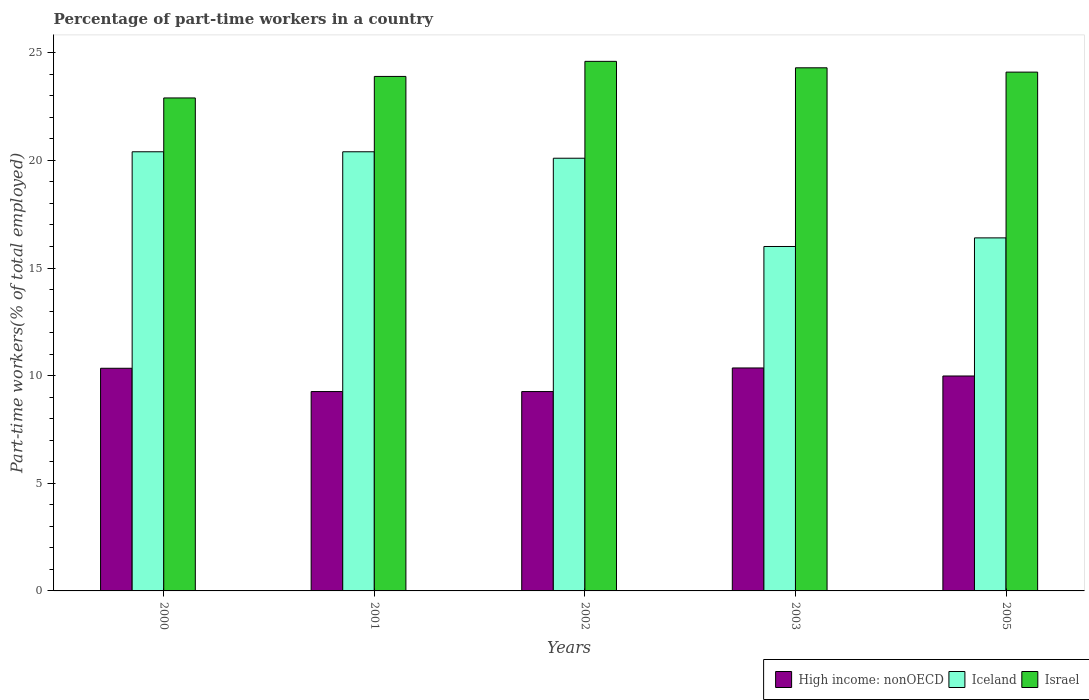How many different coloured bars are there?
Make the answer very short. 3. How many groups of bars are there?
Your answer should be compact. 5. Are the number of bars on each tick of the X-axis equal?
Your answer should be very brief. Yes. How many bars are there on the 1st tick from the left?
Offer a terse response. 3. What is the percentage of part-time workers in Israel in 2000?
Keep it short and to the point. 22.9. Across all years, what is the maximum percentage of part-time workers in High income: nonOECD?
Ensure brevity in your answer.  10.36. In which year was the percentage of part-time workers in Iceland minimum?
Give a very brief answer. 2003. What is the total percentage of part-time workers in Iceland in the graph?
Provide a succinct answer. 93.3. What is the difference between the percentage of part-time workers in Israel in 2000 and that in 2002?
Give a very brief answer. -1.7. What is the difference between the percentage of part-time workers in High income: nonOECD in 2001 and the percentage of part-time workers in Israel in 2002?
Make the answer very short. -15.34. What is the average percentage of part-time workers in High income: nonOECD per year?
Your response must be concise. 9.84. In the year 2005, what is the difference between the percentage of part-time workers in Israel and percentage of part-time workers in High income: nonOECD?
Ensure brevity in your answer.  14.12. What is the ratio of the percentage of part-time workers in Israel in 2002 to that in 2005?
Provide a short and direct response. 1.02. What is the difference between the highest and the lowest percentage of part-time workers in High income: nonOECD?
Your response must be concise. 1.1. What does the 1st bar from the left in 2002 represents?
Offer a very short reply. High income: nonOECD. What does the 3rd bar from the right in 2005 represents?
Provide a succinct answer. High income: nonOECD. Is it the case that in every year, the sum of the percentage of part-time workers in Iceland and percentage of part-time workers in Israel is greater than the percentage of part-time workers in High income: nonOECD?
Offer a very short reply. Yes. Are the values on the major ticks of Y-axis written in scientific E-notation?
Keep it short and to the point. No. Does the graph contain any zero values?
Offer a terse response. No. Does the graph contain grids?
Provide a short and direct response. No. How many legend labels are there?
Your answer should be compact. 3. How are the legend labels stacked?
Keep it short and to the point. Horizontal. What is the title of the graph?
Give a very brief answer. Percentage of part-time workers in a country. What is the label or title of the Y-axis?
Provide a short and direct response. Part-time workers(% of total employed). What is the Part-time workers(% of total employed) in High income: nonOECD in 2000?
Provide a succinct answer. 10.34. What is the Part-time workers(% of total employed) in Iceland in 2000?
Your answer should be very brief. 20.4. What is the Part-time workers(% of total employed) in Israel in 2000?
Provide a succinct answer. 22.9. What is the Part-time workers(% of total employed) in High income: nonOECD in 2001?
Ensure brevity in your answer.  9.26. What is the Part-time workers(% of total employed) of Iceland in 2001?
Your answer should be compact. 20.4. What is the Part-time workers(% of total employed) of Israel in 2001?
Ensure brevity in your answer.  23.9. What is the Part-time workers(% of total employed) of High income: nonOECD in 2002?
Offer a very short reply. 9.26. What is the Part-time workers(% of total employed) in Iceland in 2002?
Provide a succinct answer. 20.1. What is the Part-time workers(% of total employed) in Israel in 2002?
Make the answer very short. 24.6. What is the Part-time workers(% of total employed) of High income: nonOECD in 2003?
Your answer should be compact. 10.36. What is the Part-time workers(% of total employed) of Israel in 2003?
Offer a terse response. 24.3. What is the Part-time workers(% of total employed) in High income: nonOECD in 2005?
Keep it short and to the point. 9.98. What is the Part-time workers(% of total employed) of Iceland in 2005?
Keep it short and to the point. 16.4. What is the Part-time workers(% of total employed) in Israel in 2005?
Offer a very short reply. 24.1. Across all years, what is the maximum Part-time workers(% of total employed) in High income: nonOECD?
Your answer should be very brief. 10.36. Across all years, what is the maximum Part-time workers(% of total employed) in Iceland?
Make the answer very short. 20.4. Across all years, what is the maximum Part-time workers(% of total employed) of Israel?
Offer a very short reply. 24.6. Across all years, what is the minimum Part-time workers(% of total employed) in High income: nonOECD?
Offer a terse response. 9.26. Across all years, what is the minimum Part-time workers(% of total employed) of Israel?
Your response must be concise. 22.9. What is the total Part-time workers(% of total employed) of High income: nonOECD in the graph?
Your answer should be very brief. 49.21. What is the total Part-time workers(% of total employed) of Iceland in the graph?
Give a very brief answer. 93.3. What is the total Part-time workers(% of total employed) in Israel in the graph?
Your answer should be compact. 119.8. What is the difference between the Part-time workers(% of total employed) of High income: nonOECD in 2000 and that in 2001?
Make the answer very short. 1.08. What is the difference between the Part-time workers(% of total employed) in High income: nonOECD in 2000 and that in 2002?
Your answer should be compact. 1.08. What is the difference between the Part-time workers(% of total employed) in High income: nonOECD in 2000 and that in 2003?
Your answer should be compact. -0.01. What is the difference between the Part-time workers(% of total employed) of Israel in 2000 and that in 2003?
Provide a succinct answer. -1.4. What is the difference between the Part-time workers(% of total employed) in High income: nonOECD in 2000 and that in 2005?
Offer a very short reply. 0.36. What is the difference between the Part-time workers(% of total employed) in Iceland in 2000 and that in 2005?
Your answer should be very brief. 4. What is the difference between the Part-time workers(% of total employed) in High income: nonOECD in 2001 and that in 2002?
Your response must be concise. 0. What is the difference between the Part-time workers(% of total employed) in Iceland in 2001 and that in 2002?
Keep it short and to the point. 0.3. What is the difference between the Part-time workers(% of total employed) of Israel in 2001 and that in 2002?
Make the answer very short. -0.7. What is the difference between the Part-time workers(% of total employed) of High income: nonOECD in 2001 and that in 2003?
Your answer should be very brief. -1.1. What is the difference between the Part-time workers(% of total employed) of Iceland in 2001 and that in 2003?
Your response must be concise. 4.4. What is the difference between the Part-time workers(% of total employed) in High income: nonOECD in 2001 and that in 2005?
Offer a very short reply. -0.72. What is the difference between the Part-time workers(% of total employed) of Israel in 2001 and that in 2005?
Offer a terse response. -0.2. What is the difference between the Part-time workers(% of total employed) of High income: nonOECD in 2002 and that in 2003?
Provide a short and direct response. -1.1. What is the difference between the Part-time workers(% of total employed) in High income: nonOECD in 2002 and that in 2005?
Offer a very short reply. -0.72. What is the difference between the Part-time workers(% of total employed) in Iceland in 2002 and that in 2005?
Make the answer very short. 3.7. What is the difference between the Part-time workers(% of total employed) of High income: nonOECD in 2003 and that in 2005?
Ensure brevity in your answer.  0.37. What is the difference between the Part-time workers(% of total employed) of Iceland in 2003 and that in 2005?
Give a very brief answer. -0.4. What is the difference between the Part-time workers(% of total employed) of Israel in 2003 and that in 2005?
Provide a short and direct response. 0.2. What is the difference between the Part-time workers(% of total employed) of High income: nonOECD in 2000 and the Part-time workers(% of total employed) of Iceland in 2001?
Offer a terse response. -10.06. What is the difference between the Part-time workers(% of total employed) of High income: nonOECD in 2000 and the Part-time workers(% of total employed) of Israel in 2001?
Your answer should be compact. -13.56. What is the difference between the Part-time workers(% of total employed) in High income: nonOECD in 2000 and the Part-time workers(% of total employed) in Iceland in 2002?
Offer a very short reply. -9.76. What is the difference between the Part-time workers(% of total employed) in High income: nonOECD in 2000 and the Part-time workers(% of total employed) in Israel in 2002?
Give a very brief answer. -14.26. What is the difference between the Part-time workers(% of total employed) in Iceland in 2000 and the Part-time workers(% of total employed) in Israel in 2002?
Your answer should be very brief. -4.2. What is the difference between the Part-time workers(% of total employed) in High income: nonOECD in 2000 and the Part-time workers(% of total employed) in Iceland in 2003?
Your response must be concise. -5.66. What is the difference between the Part-time workers(% of total employed) in High income: nonOECD in 2000 and the Part-time workers(% of total employed) in Israel in 2003?
Keep it short and to the point. -13.96. What is the difference between the Part-time workers(% of total employed) of High income: nonOECD in 2000 and the Part-time workers(% of total employed) of Iceland in 2005?
Offer a very short reply. -6.06. What is the difference between the Part-time workers(% of total employed) in High income: nonOECD in 2000 and the Part-time workers(% of total employed) in Israel in 2005?
Provide a succinct answer. -13.76. What is the difference between the Part-time workers(% of total employed) of Iceland in 2000 and the Part-time workers(% of total employed) of Israel in 2005?
Provide a short and direct response. -3.7. What is the difference between the Part-time workers(% of total employed) of High income: nonOECD in 2001 and the Part-time workers(% of total employed) of Iceland in 2002?
Give a very brief answer. -10.84. What is the difference between the Part-time workers(% of total employed) in High income: nonOECD in 2001 and the Part-time workers(% of total employed) in Israel in 2002?
Your answer should be very brief. -15.34. What is the difference between the Part-time workers(% of total employed) in Iceland in 2001 and the Part-time workers(% of total employed) in Israel in 2002?
Give a very brief answer. -4.2. What is the difference between the Part-time workers(% of total employed) in High income: nonOECD in 2001 and the Part-time workers(% of total employed) in Iceland in 2003?
Make the answer very short. -6.74. What is the difference between the Part-time workers(% of total employed) in High income: nonOECD in 2001 and the Part-time workers(% of total employed) in Israel in 2003?
Keep it short and to the point. -15.04. What is the difference between the Part-time workers(% of total employed) of Iceland in 2001 and the Part-time workers(% of total employed) of Israel in 2003?
Your answer should be very brief. -3.9. What is the difference between the Part-time workers(% of total employed) of High income: nonOECD in 2001 and the Part-time workers(% of total employed) of Iceland in 2005?
Offer a terse response. -7.14. What is the difference between the Part-time workers(% of total employed) of High income: nonOECD in 2001 and the Part-time workers(% of total employed) of Israel in 2005?
Give a very brief answer. -14.84. What is the difference between the Part-time workers(% of total employed) in Iceland in 2001 and the Part-time workers(% of total employed) in Israel in 2005?
Your answer should be very brief. -3.7. What is the difference between the Part-time workers(% of total employed) of High income: nonOECD in 2002 and the Part-time workers(% of total employed) of Iceland in 2003?
Offer a terse response. -6.74. What is the difference between the Part-time workers(% of total employed) of High income: nonOECD in 2002 and the Part-time workers(% of total employed) of Israel in 2003?
Provide a succinct answer. -15.04. What is the difference between the Part-time workers(% of total employed) of High income: nonOECD in 2002 and the Part-time workers(% of total employed) of Iceland in 2005?
Make the answer very short. -7.14. What is the difference between the Part-time workers(% of total employed) of High income: nonOECD in 2002 and the Part-time workers(% of total employed) of Israel in 2005?
Make the answer very short. -14.84. What is the difference between the Part-time workers(% of total employed) of High income: nonOECD in 2003 and the Part-time workers(% of total employed) of Iceland in 2005?
Your answer should be very brief. -6.04. What is the difference between the Part-time workers(% of total employed) in High income: nonOECD in 2003 and the Part-time workers(% of total employed) in Israel in 2005?
Offer a very short reply. -13.74. What is the difference between the Part-time workers(% of total employed) in Iceland in 2003 and the Part-time workers(% of total employed) in Israel in 2005?
Ensure brevity in your answer.  -8.1. What is the average Part-time workers(% of total employed) in High income: nonOECD per year?
Offer a terse response. 9.84. What is the average Part-time workers(% of total employed) of Iceland per year?
Your answer should be compact. 18.66. What is the average Part-time workers(% of total employed) of Israel per year?
Keep it short and to the point. 23.96. In the year 2000, what is the difference between the Part-time workers(% of total employed) in High income: nonOECD and Part-time workers(% of total employed) in Iceland?
Provide a short and direct response. -10.06. In the year 2000, what is the difference between the Part-time workers(% of total employed) in High income: nonOECD and Part-time workers(% of total employed) in Israel?
Your answer should be very brief. -12.56. In the year 2001, what is the difference between the Part-time workers(% of total employed) in High income: nonOECD and Part-time workers(% of total employed) in Iceland?
Your answer should be very brief. -11.14. In the year 2001, what is the difference between the Part-time workers(% of total employed) of High income: nonOECD and Part-time workers(% of total employed) of Israel?
Offer a terse response. -14.64. In the year 2002, what is the difference between the Part-time workers(% of total employed) in High income: nonOECD and Part-time workers(% of total employed) in Iceland?
Give a very brief answer. -10.84. In the year 2002, what is the difference between the Part-time workers(% of total employed) of High income: nonOECD and Part-time workers(% of total employed) of Israel?
Offer a terse response. -15.34. In the year 2002, what is the difference between the Part-time workers(% of total employed) in Iceland and Part-time workers(% of total employed) in Israel?
Your answer should be compact. -4.5. In the year 2003, what is the difference between the Part-time workers(% of total employed) in High income: nonOECD and Part-time workers(% of total employed) in Iceland?
Give a very brief answer. -5.64. In the year 2003, what is the difference between the Part-time workers(% of total employed) of High income: nonOECD and Part-time workers(% of total employed) of Israel?
Make the answer very short. -13.94. In the year 2003, what is the difference between the Part-time workers(% of total employed) in Iceland and Part-time workers(% of total employed) in Israel?
Your answer should be compact. -8.3. In the year 2005, what is the difference between the Part-time workers(% of total employed) in High income: nonOECD and Part-time workers(% of total employed) in Iceland?
Make the answer very short. -6.42. In the year 2005, what is the difference between the Part-time workers(% of total employed) in High income: nonOECD and Part-time workers(% of total employed) in Israel?
Your answer should be compact. -14.12. What is the ratio of the Part-time workers(% of total employed) of High income: nonOECD in 2000 to that in 2001?
Offer a terse response. 1.12. What is the ratio of the Part-time workers(% of total employed) of Israel in 2000 to that in 2001?
Provide a succinct answer. 0.96. What is the ratio of the Part-time workers(% of total employed) of High income: nonOECD in 2000 to that in 2002?
Make the answer very short. 1.12. What is the ratio of the Part-time workers(% of total employed) in Iceland in 2000 to that in 2002?
Offer a terse response. 1.01. What is the ratio of the Part-time workers(% of total employed) of Israel in 2000 to that in 2002?
Provide a short and direct response. 0.93. What is the ratio of the Part-time workers(% of total employed) in High income: nonOECD in 2000 to that in 2003?
Your answer should be compact. 1. What is the ratio of the Part-time workers(% of total employed) of Iceland in 2000 to that in 2003?
Make the answer very short. 1.27. What is the ratio of the Part-time workers(% of total employed) of Israel in 2000 to that in 2003?
Provide a short and direct response. 0.94. What is the ratio of the Part-time workers(% of total employed) of High income: nonOECD in 2000 to that in 2005?
Ensure brevity in your answer.  1.04. What is the ratio of the Part-time workers(% of total employed) in Iceland in 2000 to that in 2005?
Ensure brevity in your answer.  1.24. What is the ratio of the Part-time workers(% of total employed) of Israel in 2000 to that in 2005?
Offer a very short reply. 0.95. What is the ratio of the Part-time workers(% of total employed) of Iceland in 2001 to that in 2002?
Your response must be concise. 1.01. What is the ratio of the Part-time workers(% of total employed) in Israel in 2001 to that in 2002?
Provide a short and direct response. 0.97. What is the ratio of the Part-time workers(% of total employed) in High income: nonOECD in 2001 to that in 2003?
Your response must be concise. 0.89. What is the ratio of the Part-time workers(% of total employed) in Iceland in 2001 to that in 2003?
Provide a short and direct response. 1.27. What is the ratio of the Part-time workers(% of total employed) in Israel in 2001 to that in 2003?
Keep it short and to the point. 0.98. What is the ratio of the Part-time workers(% of total employed) in High income: nonOECD in 2001 to that in 2005?
Your response must be concise. 0.93. What is the ratio of the Part-time workers(% of total employed) in Iceland in 2001 to that in 2005?
Your response must be concise. 1.24. What is the ratio of the Part-time workers(% of total employed) in High income: nonOECD in 2002 to that in 2003?
Your response must be concise. 0.89. What is the ratio of the Part-time workers(% of total employed) in Iceland in 2002 to that in 2003?
Provide a short and direct response. 1.26. What is the ratio of the Part-time workers(% of total employed) in Israel in 2002 to that in 2003?
Provide a short and direct response. 1.01. What is the ratio of the Part-time workers(% of total employed) in High income: nonOECD in 2002 to that in 2005?
Keep it short and to the point. 0.93. What is the ratio of the Part-time workers(% of total employed) in Iceland in 2002 to that in 2005?
Provide a short and direct response. 1.23. What is the ratio of the Part-time workers(% of total employed) in Israel in 2002 to that in 2005?
Your response must be concise. 1.02. What is the ratio of the Part-time workers(% of total employed) in High income: nonOECD in 2003 to that in 2005?
Provide a short and direct response. 1.04. What is the ratio of the Part-time workers(% of total employed) of Iceland in 2003 to that in 2005?
Give a very brief answer. 0.98. What is the ratio of the Part-time workers(% of total employed) in Israel in 2003 to that in 2005?
Provide a short and direct response. 1.01. What is the difference between the highest and the second highest Part-time workers(% of total employed) of High income: nonOECD?
Make the answer very short. 0.01. What is the difference between the highest and the second highest Part-time workers(% of total employed) in Israel?
Give a very brief answer. 0.3. What is the difference between the highest and the lowest Part-time workers(% of total employed) in High income: nonOECD?
Offer a very short reply. 1.1. What is the difference between the highest and the lowest Part-time workers(% of total employed) in Iceland?
Offer a terse response. 4.4. What is the difference between the highest and the lowest Part-time workers(% of total employed) of Israel?
Your answer should be compact. 1.7. 